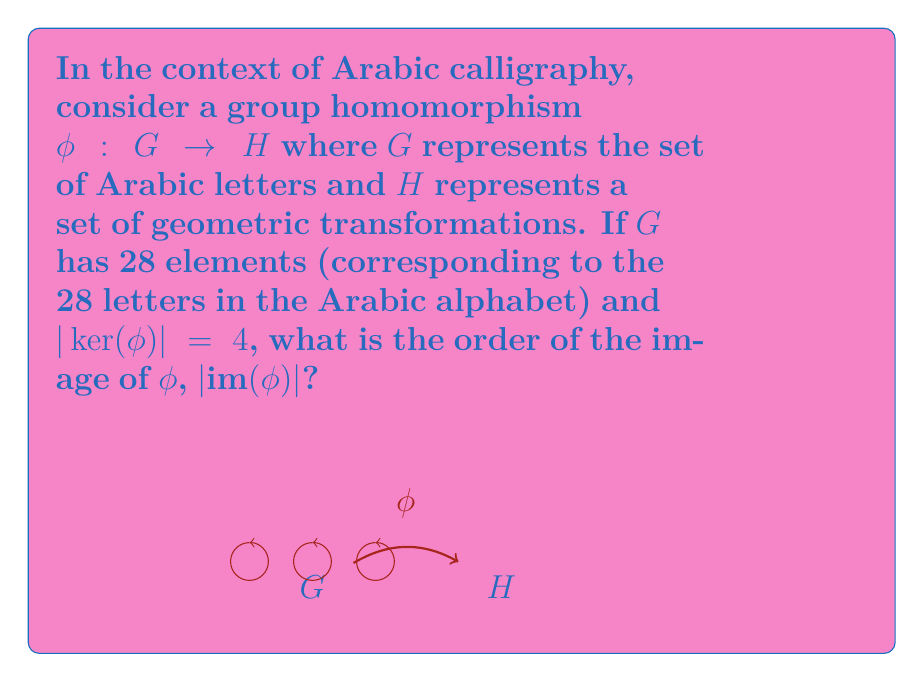Provide a solution to this math problem. Let's approach this step-by-step using the First Isomorphism Theorem:

1) The First Isomorphism Theorem states that for a group homomorphism $\phi: G \rightarrow H$, we have:

   $$G/\ker(\phi) \cong \text{im}(\phi)$$

2) This implies that:

   $$|\text{im}(\phi)| = |G/\ker(\phi)|$$

3) We know that for any subgroup $K$ of a finite group $G$:

   $$|G| = |G/K| \cdot |K|$$

4) In our case, $|G| = 28$ (the number of letters in the Arabic alphabet) and $|\ker(\phi)| = 4$. Let's substitute these into the equation from step 3:

   $$28 = |G/\ker(\phi)| \cdot 4$$

5) Solving for $|G/\ker(\phi)|$:

   $$|G/\ker(\phi)| = 28/4 = 7$$

6) From step 2, we know that $|\text{im}(\phi)| = |G/\ker(\phi)|$, so:

   $$|\text{im}(\phi)| = 7$$

Therefore, the order of the image of $\phi$ is 7.
Answer: 7 